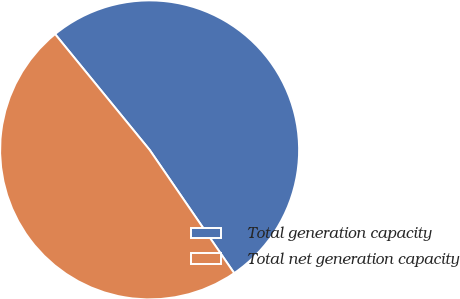Convert chart. <chart><loc_0><loc_0><loc_500><loc_500><pie_chart><fcel>Total generation capacity<fcel>Total net generation capacity<nl><fcel>51.33%<fcel>48.67%<nl></chart> 